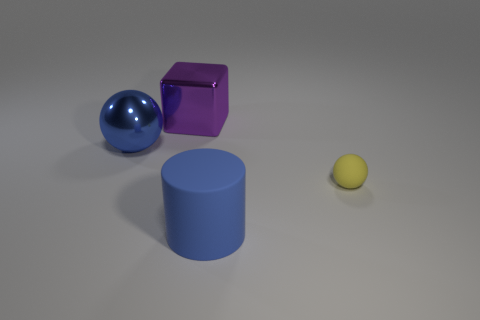Add 4 tiny matte spheres. How many objects exist? 8 Subtract all cylinders. How many objects are left? 3 Subtract 0 green cubes. How many objects are left? 4 Subtract all big brown matte cylinders. Subtract all metallic cubes. How many objects are left? 3 Add 2 large purple metal cubes. How many large purple metal cubes are left? 3 Add 4 rubber objects. How many rubber objects exist? 6 